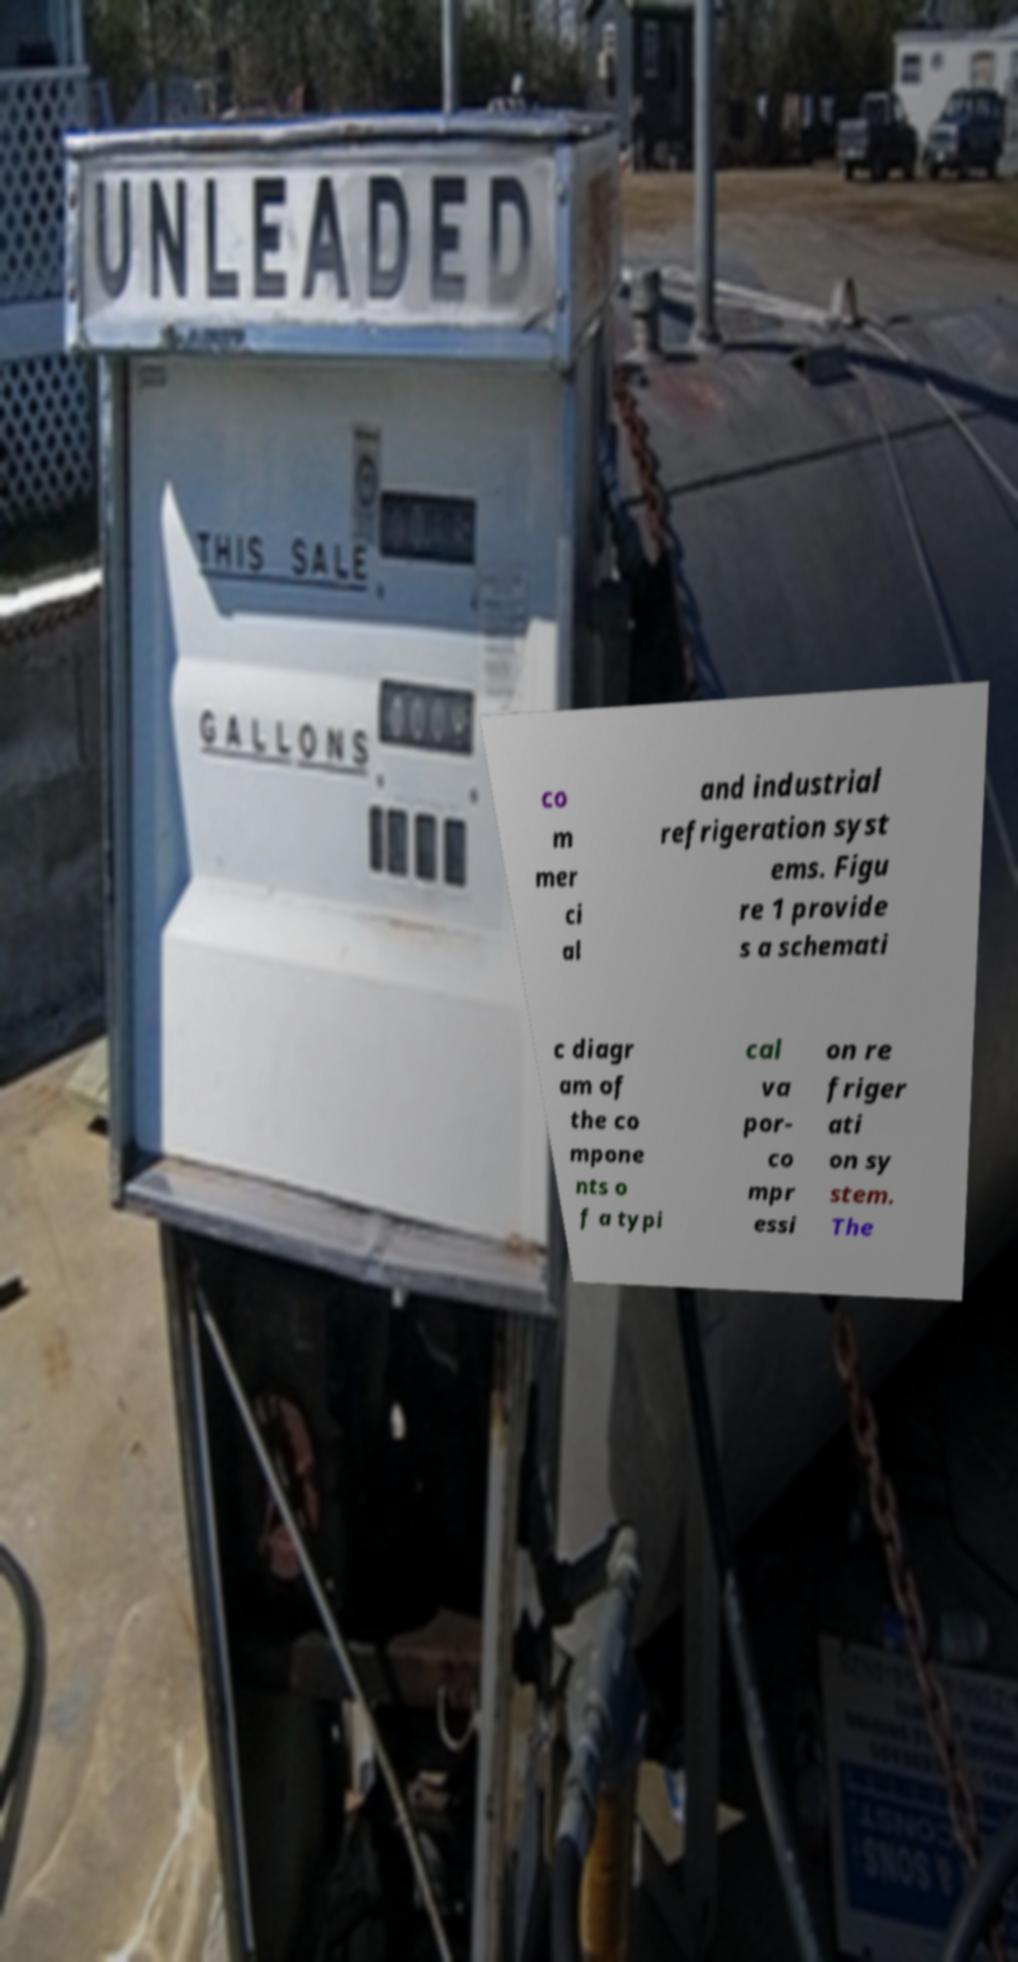Can you read and provide the text displayed in the image?This photo seems to have some interesting text. Can you extract and type it out for me? co m mer ci al and industrial refrigeration syst ems. Figu re 1 provide s a schemati c diagr am of the co mpone nts o f a typi cal va por- co mpr essi on re friger ati on sy stem. The 